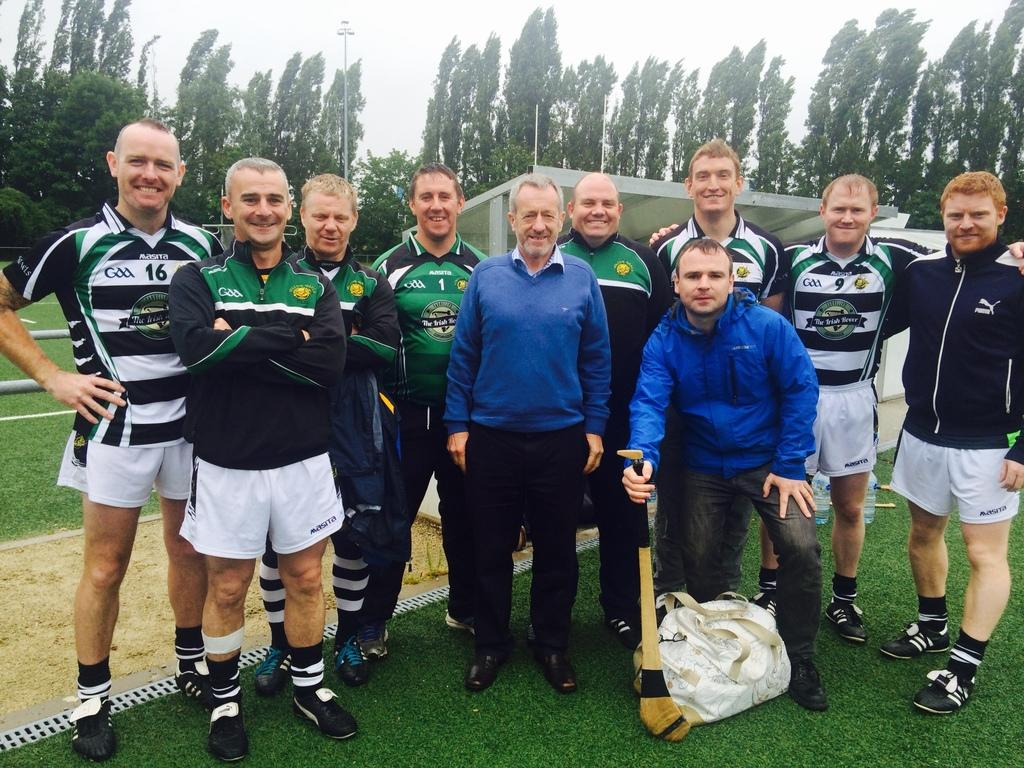What are the people in the image doing? The people in the image are standing in the grass. What object is one person holding? One person is holding a bat. What can be seen in the background of the image? There is a tent and trees visible in the background. What type of corn is growing in the room in the image? There is no corn or room present in the image; it features people standing in the grass with a tent and trees in the background. 